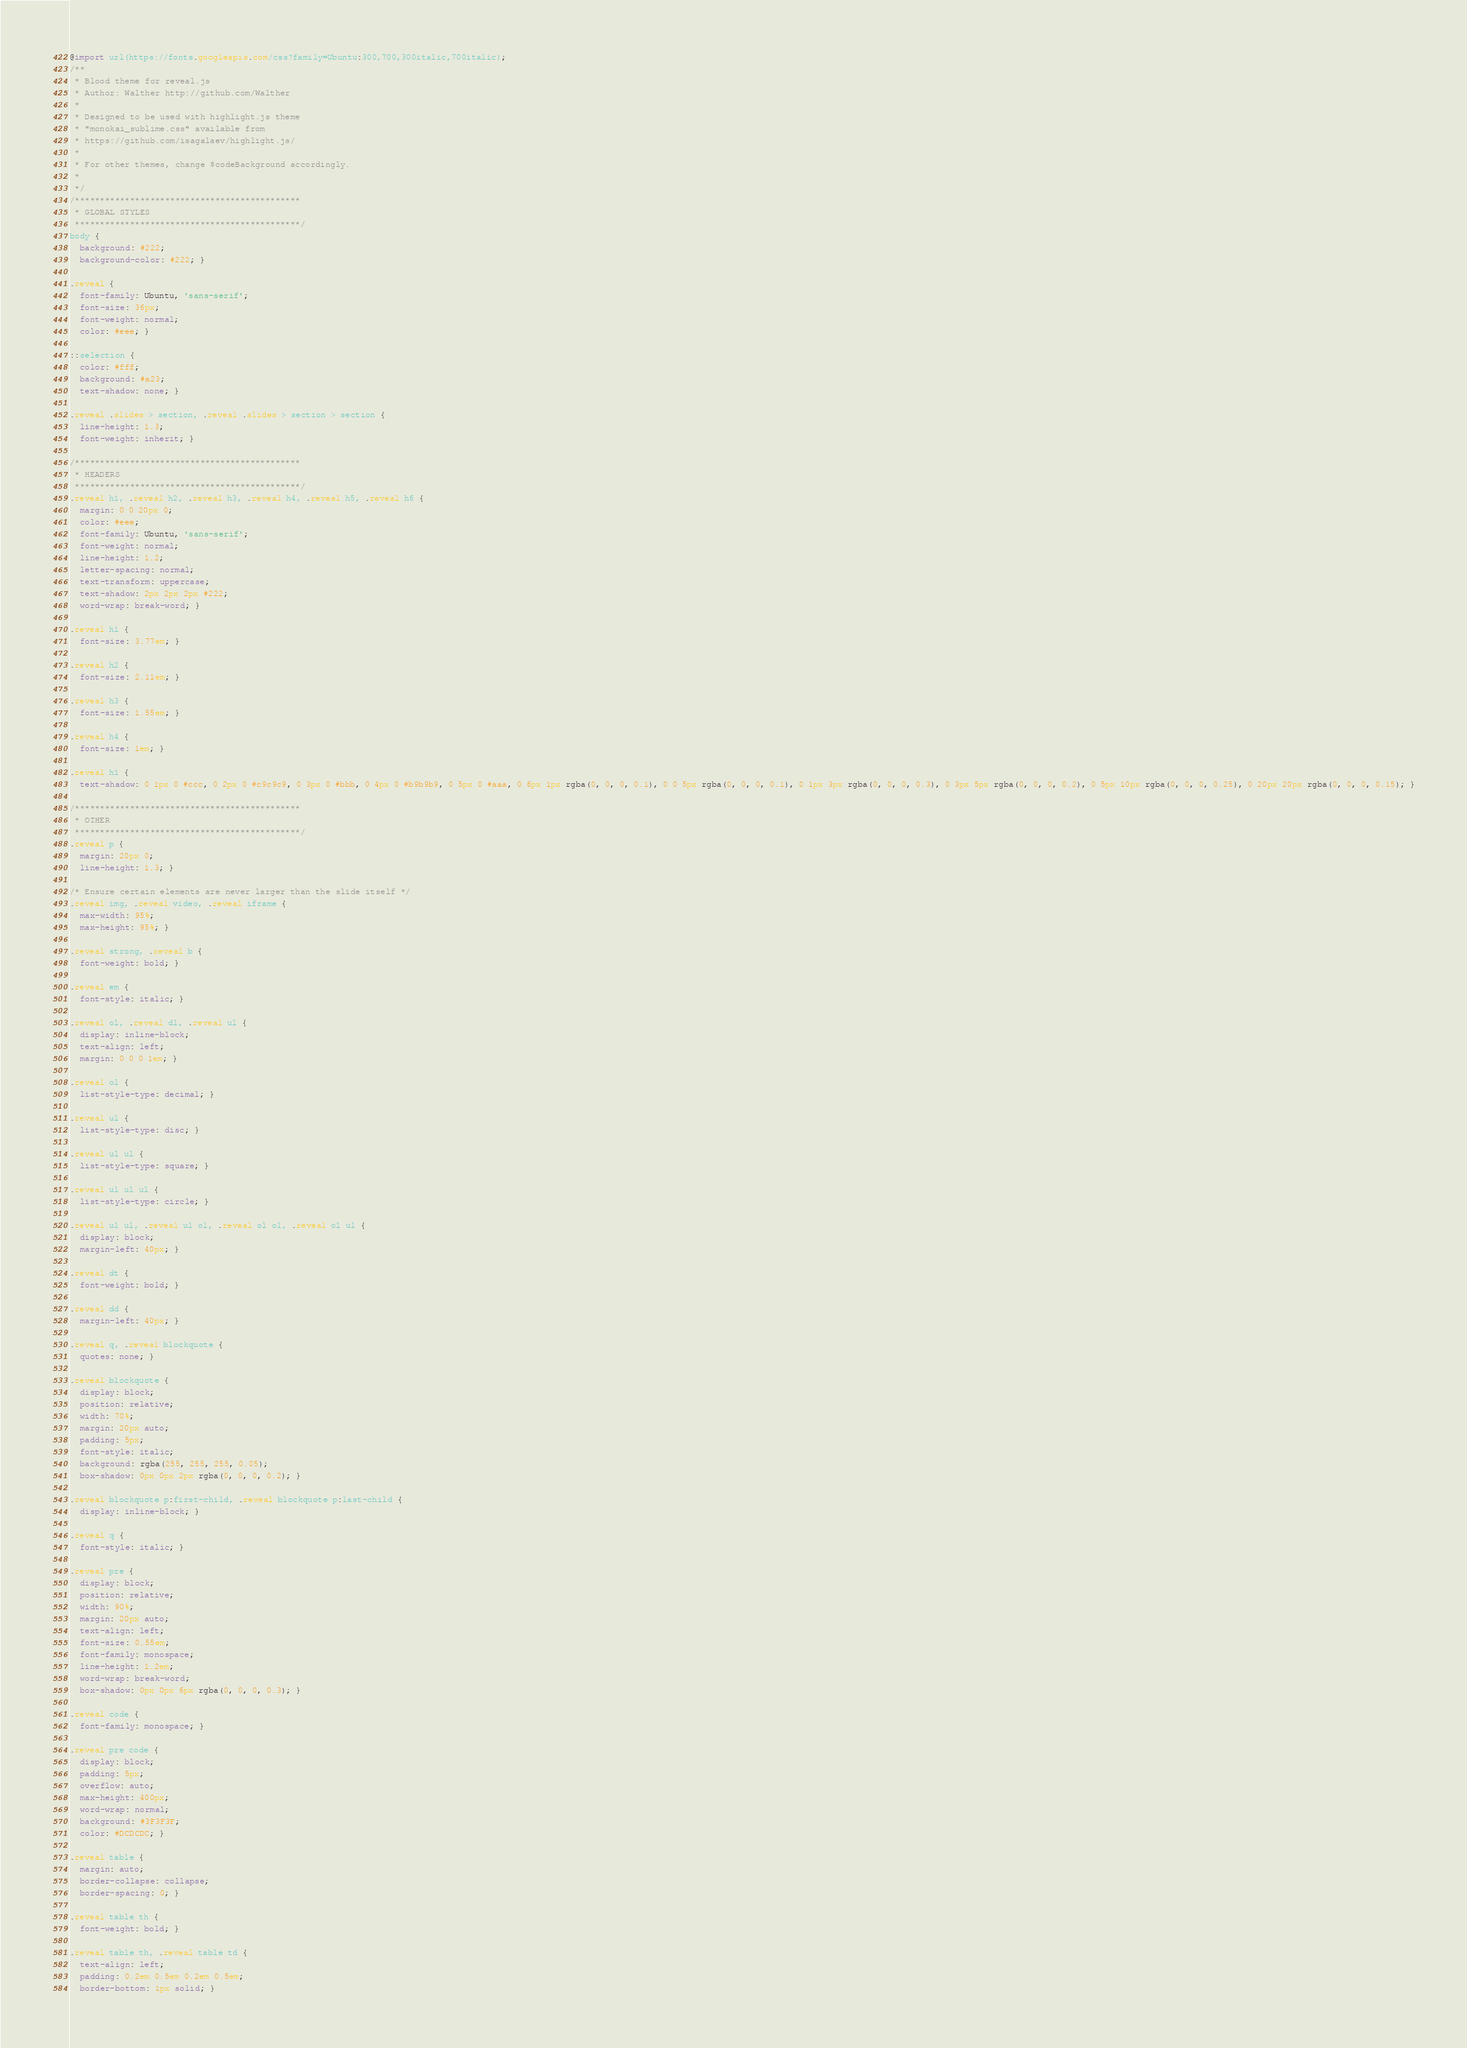Convert code to text. <code><loc_0><loc_0><loc_500><loc_500><_CSS_>@import url(https://fonts.googleapis.com/css?family=Ubuntu:300,700,300italic,700italic);
/**
 * Blood theme for reveal.js
 * Author: Walther http://github.com/Walther
 *
 * Designed to be used with highlight.js theme
 * "monokai_sublime.css" available from
 * https://github.com/isagalaev/highlight.js/
 *
 * For other themes, change $codeBackground accordingly.
 *
 */
/*********************************************
 * GLOBAL STYLES
 *********************************************/
body {
  background: #222;
  background-color: #222; }

.reveal {
  font-family: Ubuntu, 'sans-serif';
  font-size: 36px;
  font-weight: normal;
  color: #eee; }

::selection {
  color: #fff;
  background: #a23;
  text-shadow: none; }

.reveal .slides > section, .reveal .slides > section > section {
  line-height: 1.3;
  font-weight: inherit; }

/*********************************************
 * HEADERS
 *********************************************/
.reveal h1, .reveal h2, .reveal h3, .reveal h4, .reveal h5, .reveal h6 {
  margin: 0 0 20px 0;
  color: #eee;
  font-family: Ubuntu, 'sans-serif';
  font-weight: normal;
  line-height: 1.2;
  letter-spacing: normal;
  text-transform: uppercase;
  text-shadow: 2px 2px 2px #222;
  word-wrap: break-word; }

.reveal h1 {
  font-size: 3.77em; }

.reveal h2 {
  font-size: 2.11em; }

.reveal h3 {
  font-size: 1.55em; }

.reveal h4 {
  font-size: 1em; }

.reveal h1 {
  text-shadow: 0 1px 0 #ccc, 0 2px 0 #c9c9c9, 0 3px 0 #bbb, 0 4px 0 #b9b9b9, 0 5px 0 #aaa, 0 6px 1px rgba(0, 0, 0, 0.1), 0 0 5px rgba(0, 0, 0, 0.1), 0 1px 3px rgba(0, 0, 0, 0.3), 0 3px 5px rgba(0, 0, 0, 0.2), 0 5px 10px rgba(0, 0, 0, 0.25), 0 20px 20px rgba(0, 0, 0, 0.15); }

/*********************************************
 * OTHER
 *********************************************/
.reveal p {
  margin: 20px 0;
  line-height: 1.3; }

/* Ensure certain elements are never larger than the slide itself */
.reveal img, .reveal video, .reveal iframe {
  max-width: 95%;
  max-height: 95%; }

.reveal strong, .reveal b {
  font-weight: bold; }

.reveal em {
  font-style: italic; }

.reveal ol, .reveal dl, .reveal ul {
  display: inline-block;
  text-align: left;
  margin: 0 0 0 1em; }

.reveal ol {
  list-style-type: decimal; }

.reveal ul {
  list-style-type: disc; }

.reveal ul ul {
  list-style-type: square; }

.reveal ul ul ul {
  list-style-type: circle; }

.reveal ul ul, .reveal ul ol, .reveal ol ol, .reveal ol ul {
  display: block;
  margin-left: 40px; }

.reveal dt {
  font-weight: bold; }

.reveal dd {
  margin-left: 40px; }

.reveal q, .reveal blockquote {
  quotes: none; }

.reveal blockquote {
  display: block;
  position: relative;
  width: 70%;
  margin: 20px auto;
  padding: 5px;
  font-style: italic;
  background: rgba(255, 255, 255, 0.05);
  box-shadow: 0px 0px 2px rgba(0, 0, 0, 0.2); }

.reveal blockquote p:first-child, .reveal blockquote p:last-child {
  display: inline-block; }

.reveal q {
  font-style: italic; }

.reveal pre {
  display: block;
  position: relative;
  width: 90%;
  margin: 20px auto;
  text-align: left;
  font-size: 0.55em;
  font-family: monospace;
  line-height: 1.2em;
  word-wrap: break-word;
  box-shadow: 0px 0px 6px rgba(0, 0, 0, 0.3); }

.reveal code {
  font-family: monospace; }

.reveal pre code {
  display: block;
  padding: 5px;
  overflow: auto;
  max-height: 400px;
  word-wrap: normal;
  background: #3F3F3F;
  color: #DCDCDC; }

.reveal table {
  margin: auto;
  border-collapse: collapse;
  border-spacing: 0; }

.reveal table th {
  font-weight: bold; }

.reveal table th, .reveal table td {
  text-align: left;
  padding: 0.2em 0.5em 0.2em 0.5em;
  border-bottom: 1px solid; }
</code> 